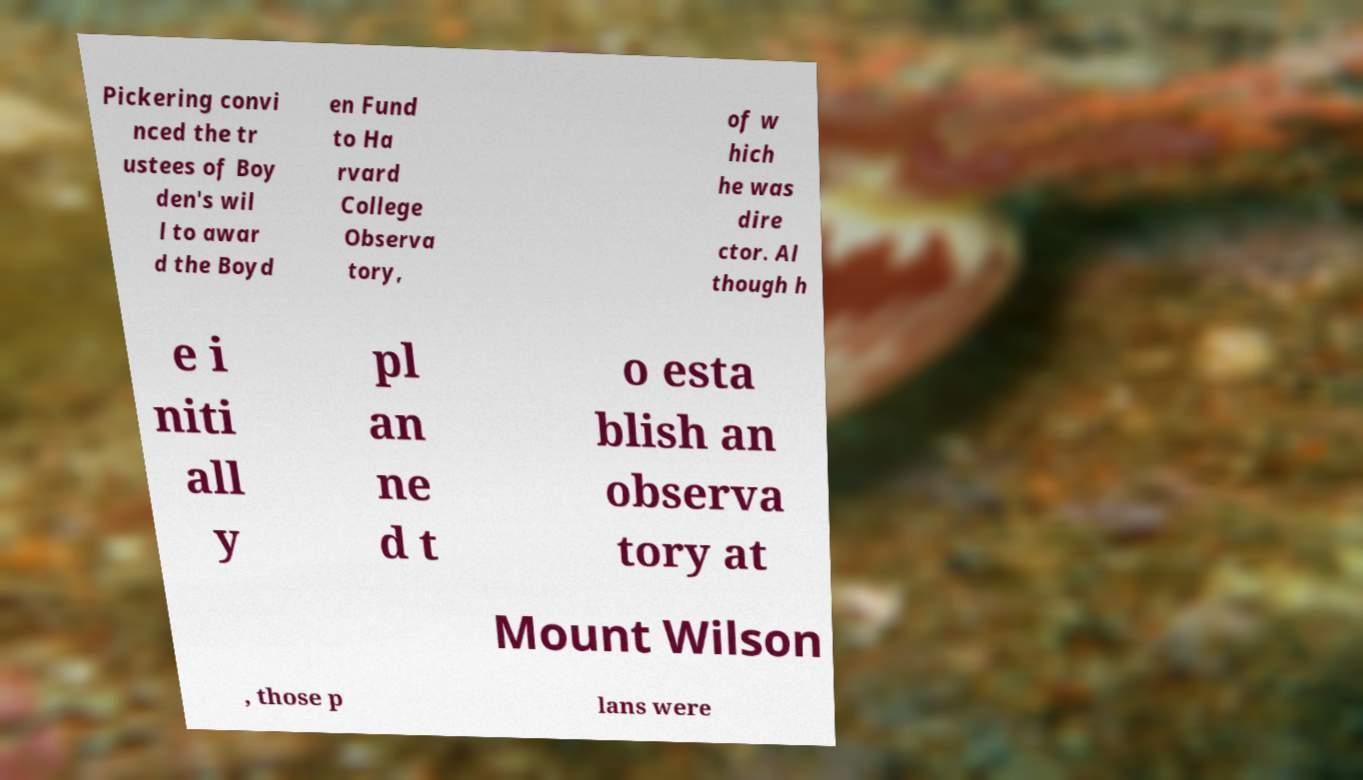Please identify and transcribe the text found in this image. Pickering convi nced the tr ustees of Boy den's wil l to awar d the Boyd en Fund to Ha rvard College Observa tory, of w hich he was dire ctor. Al though h e i niti all y pl an ne d t o esta blish an observa tory at Mount Wilson , those p lans were 